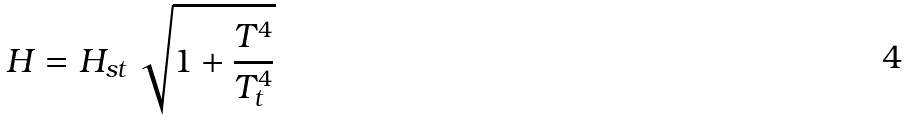Convert formula to latex. <formula><loc_0><loc_0><loc_500><loc_500>H = H _ { s t } \, \sqrt { 1 + \frac { T ^ { 4 } } { T _ { t } ^ { 4 } } }</formula> 